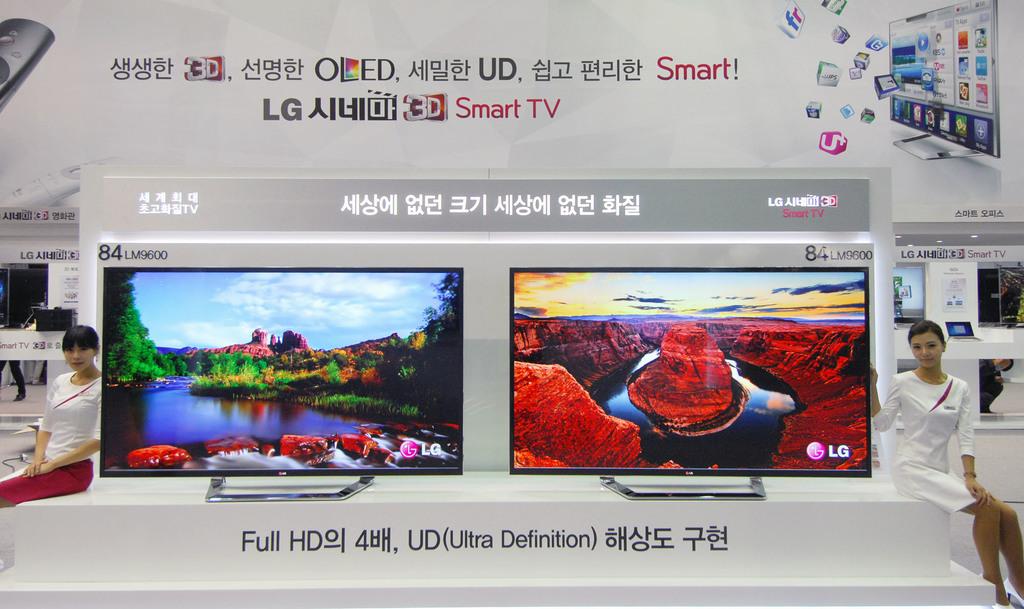What definition is this tv?
Ensure brevity in your answer.  Ultra. What are the brands of tv?
Offer a very short reply. Lg. 